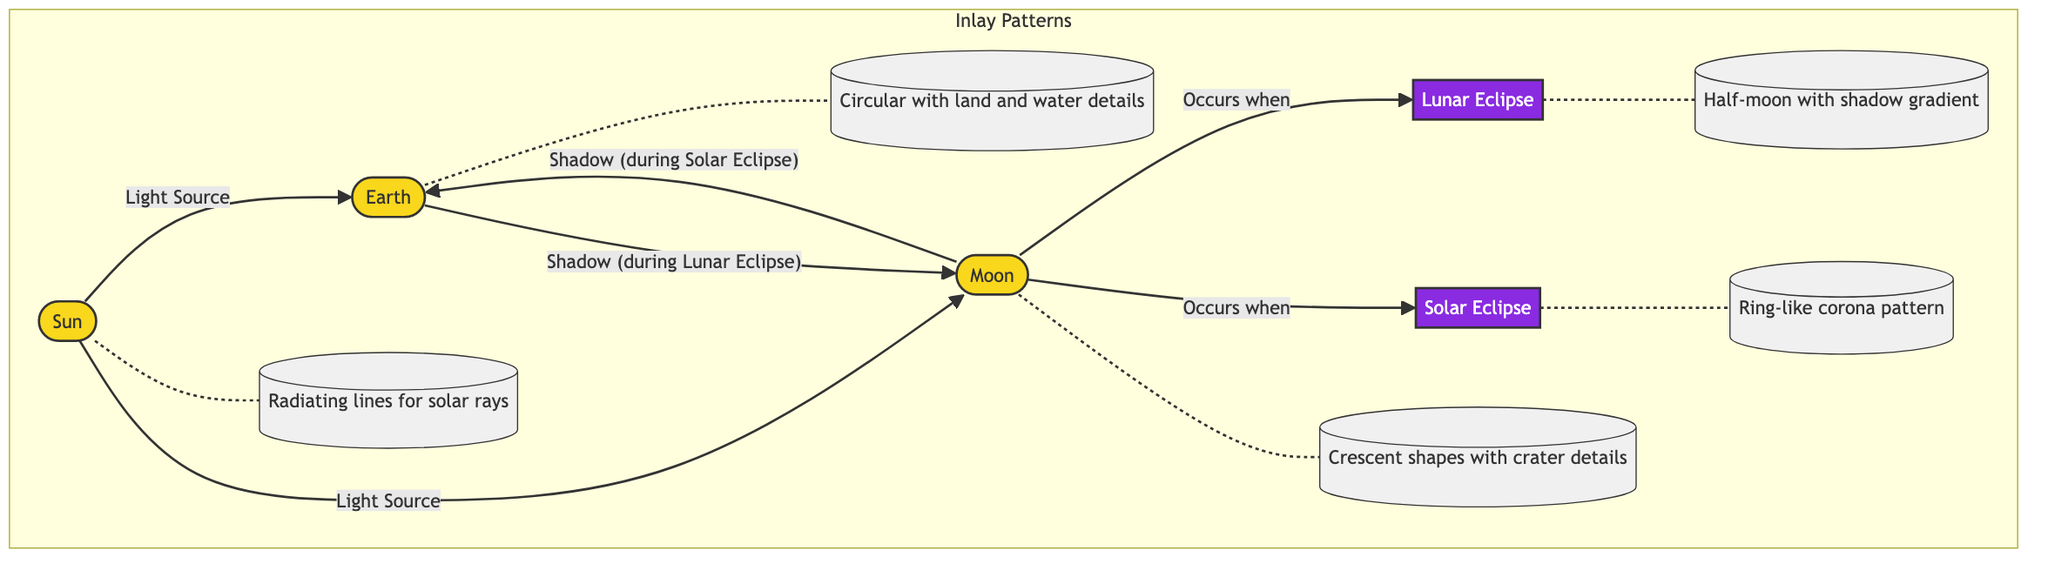What is the color of the Sun node? The Sun node is represented in the diagram with a fill color that corresponds to the class "planet", which is #f9d71c (a shade of yellow).
Answer: yellow How many eclipses are depicted in the diagram? There are two types of eclipses represented in the diagram: Lunar Eclipse and Solar Eclipse, making a total of 2 eclipses.
Answer: 2 What relationship exists between the Moon and the Earth during a Solar Eclipse? The diagram shows that the Moon casts a shadow on the Earth during a Solar Eclipse. This establishes a direct connection between the Moon and the Earth through the concept of shadow.
Answer: Shadow Which pattern represents the Lunar Eclipse? The intricate inlay pattern representing the Lunar Eclipse is described as a "Half-moon with shadow gradient" according to the subgraph inlay patterns.
Answer: Half-moon with shadow gradient Where do the light rays from the Sun travel in this diagram? The diagram indicates that the light rays from the Sun travel toward both the Earth and the Moon, showing their role as the light source for both phenomena.
Answer: Earth and Moon What shapes represent the Moon in the inlay patterns? The Moon is represented with crescent shapes that have crater details, illustrating the specifics of the inlay pattern for the Moon.
Answer: Crescent shapes with crater details Explain how a Lunar Eclipse occurs based on the diagram. The diagram illustrates that a Lunar Eclipse occurs when the Moon is positioned behind the Earth in relation to the Sun. This means that the Earth's shadow is cast onto the Moon, blocking the Sun's light.
Answer: Moon behind Earth What do the radiating lines on the Sun represent? In the diagram, the Sun features radiating lines that symbolize solar rays, emphasizing the Sun's role as the source of light during both Lunar and Solar Eclipses.
Answer: Radiating lines for solar rays What is the visual difference in patterns between the Solar and Lunar Eclipses? The Solar Eclipse is visually represented with a "Ring-like corona pattern" while the Lunar Eclipse shows a "Half-moon with shadow gradient," highlighting their distinct appearances in the diagram.
Answer: Ring-like corona pattern and Half-moon with shadow gradient 